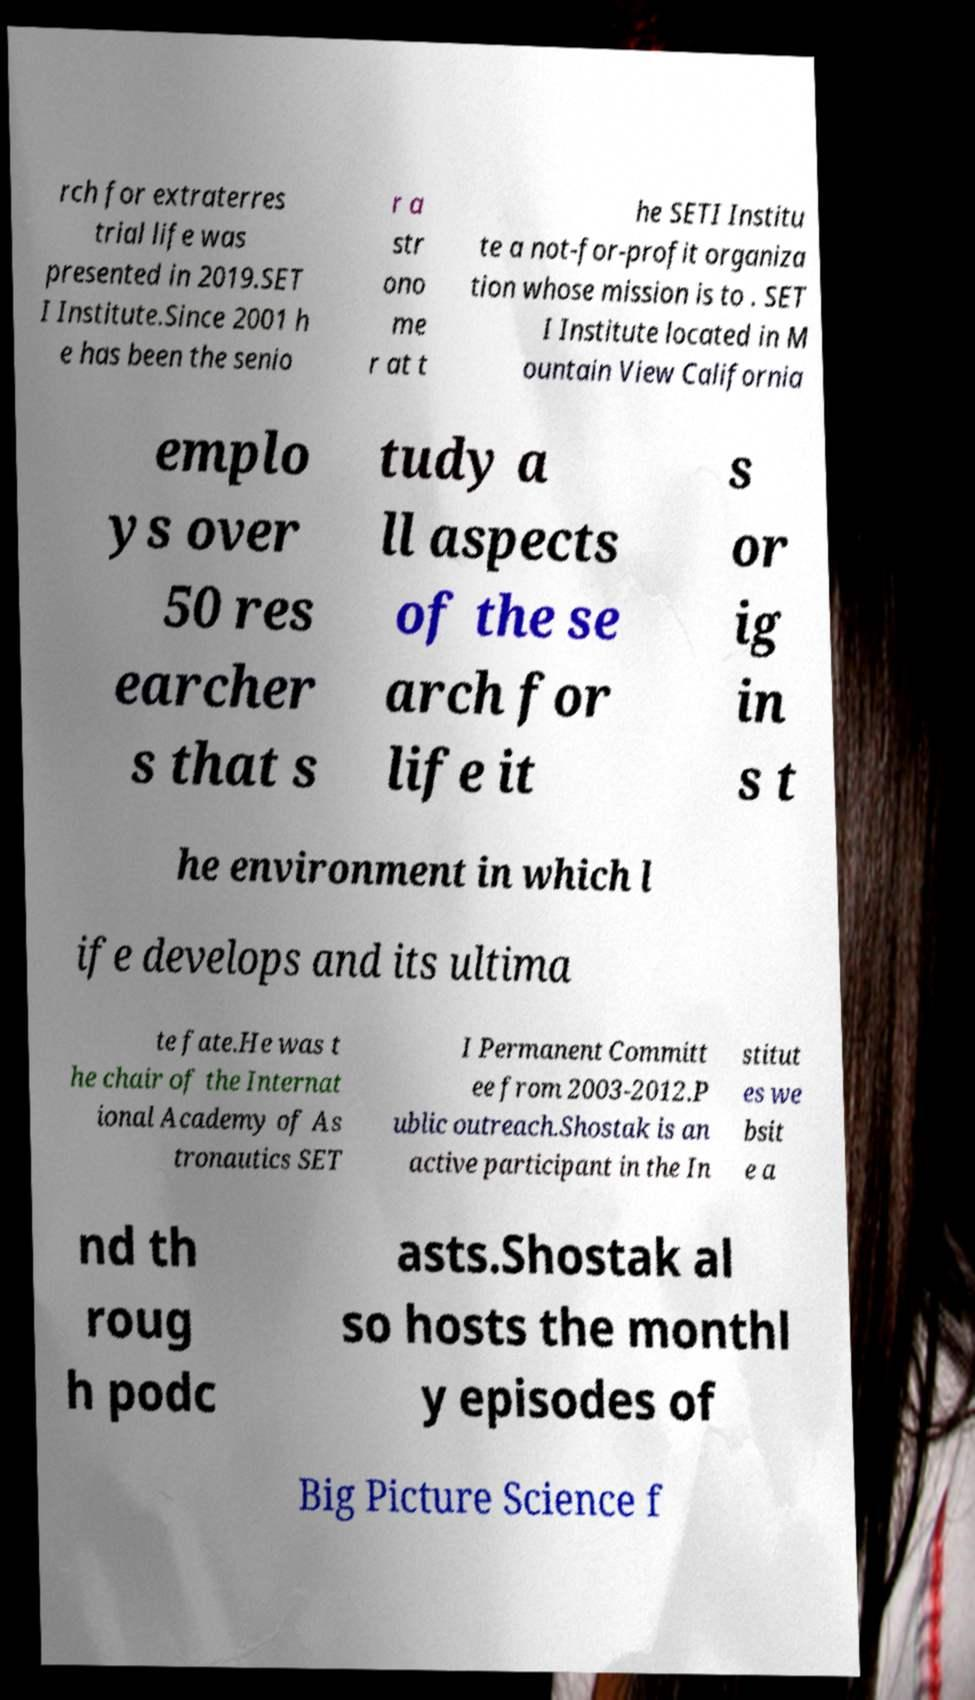For documentation purposes, I need the text within this image transcribed. Could you provide that? rch for extraterres trial life was presented in 2019.SET I Institute.Since 2001 h e has been the senio r a str ono me r at t he SETI Institu te a not-for-profit organiza tion whose mission is to . SET I Institute located in M ountain View California emplo ys over 50 res earcher s that s tudy a ll aspects of the se arch for life it s or ig in s t he environment in which l ife develops and its ultima te fate.He was t he chair of the Internat ional Academy of As tronautics SET I Permanent Committ ee from 2003-2012.P ublic outreach.Shostak is an active participant in the In stitut es we bsit e a nd th roug h podc asts.Shostak al so hosts the monthl y episodes of Big Picture Science f 